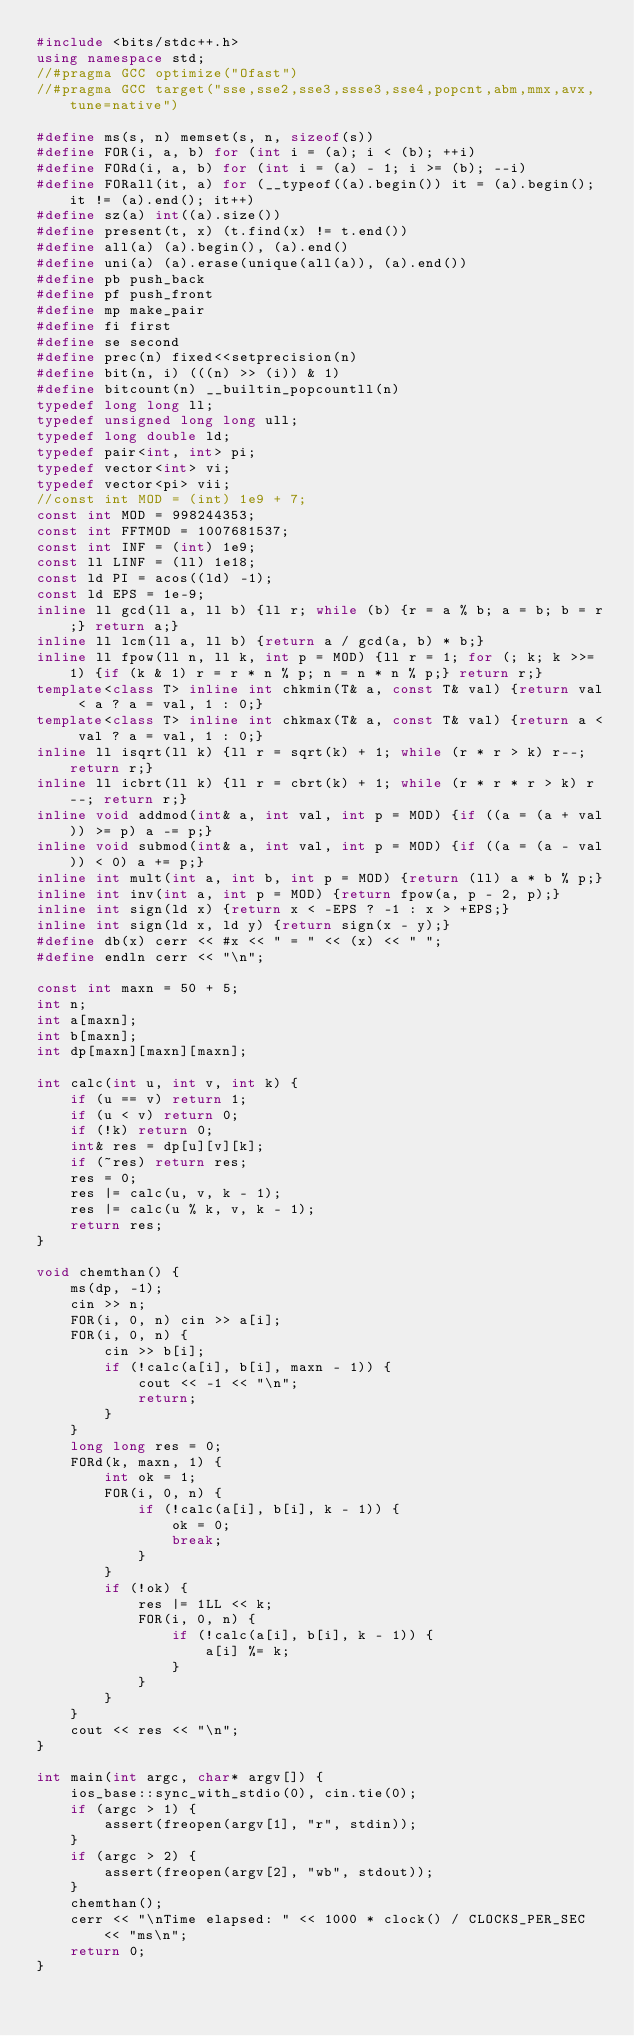<code> <loc_0><loc_0><loc_500><loc_500><_C++_>#include <bits/stdc++.h>
using namespace std;
//#pragma GCC optimize("Ofast")
//#pragma GCC target("sse,sse2,sse3,ssse3,sse4,popcnt,abm,mmx,avx,tune=native")

#define ms(s, n) memset(s, n, sizeof(s))
#define FOR(i, a, b) for (int i = (a); i < (b); ++i)
#define FORd(i, a, b) for (int i = (a) - 1; i >= (b); --i)
#define FORall(it, a) for (__typeof((a).begin()) it = (a).begin(); it != (a).end(); it++)
#define sz(a) int((a).size())
#define present(t, x) (t.find(x) != t.end())
#define all(a) (a).begin(), (a).end()
#define uni(a) (a).erase(unique(all(a)), (a).end())
#define pb push_back
#define pf push_front
#define mp make_pair
#define fi first
#define se second
#define prec(n) fixed<<setprecision(n)
#define bit(n, i) (((n) >> (i)) & 1)
#define bitcount(n) __builtin_popcountll(n)
typedef long long ll;
typedef unsigned long long ull;
typedef long double ld;
typedef pair<int, int> pi;
typedef vector<int> vi;
typedef vector<pi> vii;
//const int MOD = (int) 1e9 + 7;
const int MOD = 998244353;
const int FFTMOD = 1007681537;
const int INF = (int) 1e9;
const ll LINF = (ll) 1e18;
const ld PI = acos((ld) -1);
const ld EPS = 1e-9;
inline ll gcd(ll a, ll b) {ll r; while (b) {r = a % b; a = b; b = r;} return a;}
inline ll lcm(ll a, ll b) {return a / gcd(a, b) * b;}
inline ll fpow(ll n, ll k, int p = MOD) {ll r = 1; for (; k; k >>= 1) {if (k & 1) r = r * n % p; n = n * n % p;} return r;}
template<class T> inline int chkmin(T& a, const T& val) {return val < a ? a = val, 1 : 0;}
template<class T> inline int chkmax(T& a, const T& val) {return a < val ? a = val, 1 : 0;}
inline ll isqrt(ll k) {ll r = sqrt(k) + 1; while (r * r > k) r--; return r;}
inline ll icbrt(ll k) {ll r = cbrt(k) + 1; while (r * r * r > k) r--; return r;}
inline void addmod(int& a, int val, int p = MOD) {if ((a = (a + val)) >= p) a -= p;}
inline void submod(int& a, int val, int p = MOD) {if ((a = (a - val)) < 0) a += p;}
inline int mult(int a, int b, int p = MOD) {return (ll) a * b % p;}
inline int inv(int a, int p = MOD) {return fpow(a, p - 2, p);}
inline int sign(ld x) {return x < -EPS ? -1 : x > +EPS;}
inline int sign(ld x, ld y) {return sign(x - y);}
#define db(x) cerr << #x << " = " << (x) << " ";
#define endln cerr << "\n";

const int maxn = 50 + 5;
int n;
int a[maxn];
int b[maxn];
int dp[maxn][maxn][maxn];

int calc(int u, int v, int k) {
    if (u == v) return 1;
    if (u < v) return 0;
    if (!k) return 0;
    int& res = dp[u][v][k];
    if (~res) return res;
    res = 0;
    res |= calc(u, v, k - 1);
    res |= calc(u % k, v, k - 1);
    return res;
}

void chemthan() {
    ms(dp, -1);
    cin >> n;
    FOR(i, 0, n) cin >> a[i];
    FOR(i, 0, n) {
        cin >> b[i];
        if (!calc(a[i], b[i], maxn - 1)) {
            cout << -1 << "\n";
            return;
        }
    }
    long long res = 0;
    FORd(k, maxn, 1) {
        int ok = 1;
        FOR(i, 0, n) {
            if (!calc(a[i], b[i], k - 1)) {
                ok = 0;
                break;
            }
        }
        if (!ok) {
            res |= 1LL << k;
            FOR(i, 0, n) {
                if (!calc(a[i], b[i], k - 1)) {
                    a[i] %= k;
                }
            }
        }
    }
    cout << res << "\n";
}

int main(int argc, char* argv[]) {
    ios_base::sync_with_stdio(0), cin.tie(0);
    if (argc > 1) {
        assert(freopen(argv[1], "r", stdin));
    }
    if (argc > 2) {
        assert(freopen(argv[2], "wb", stdout));
    }
    chemthan();
    cerr << "\nTime elapsed: " << 1000 * clock() / CLOCKS_PER_SEC << "ms\n";
    return 0;
} 
</code> 